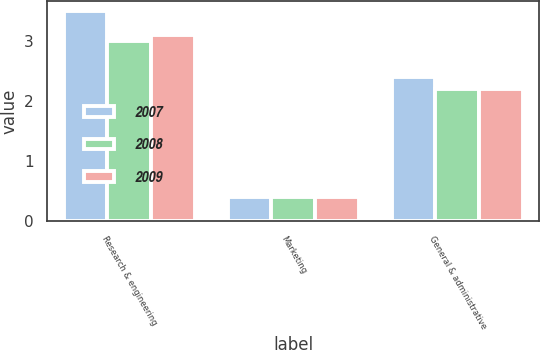Convert chart to OTSL. <chart><loc_0><loc_0><loc_500><loc_500><stacked_bar_chart><ecel><fcel>Research & engineering<fcel>Marketing<fcel>General & administrative<nl><fcel>2007<fcel>3.5<fcel>0.4<fcel>2.4<nl><fcel>2008<fcel>3<fcel>0.4<fcel>2.2<nl><fcel>2009<fcel>3.1<fcel>0.4<fcel>2.2<nl></chart> 